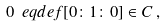<formula> <loc_0><loc_0><loc_500><loc_500>0 \ e q d e f [ 0 \colon 1 \colon 0 ] \in C \, ,</formula> 